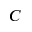Convert formula to latex. <formula><loc_0><loc_0><loc_500><loc_500>C</formula> 